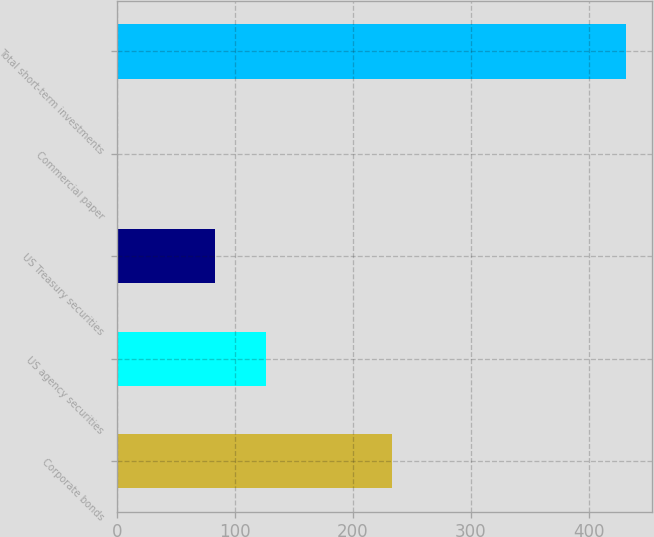Convert chart to OTSL. <chart><loc_0><loc_0><loc_500><loc_500><bar_chart><fcel>Corporate bonds<fcel>US agency securities<fcel>US Treasury securities<fcel>Commercial paper<fcel>Total short-term investments<nl><fcel>233<fcel>126.1<fcel>83<fcel>1<fcel>432<nl></chart> 